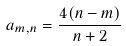<formula> <loc_0><loc_0><loc_500><loc_500>a _ { m , n } = \frac { 4 ( n - m ) } { n + 2 }</formula> 